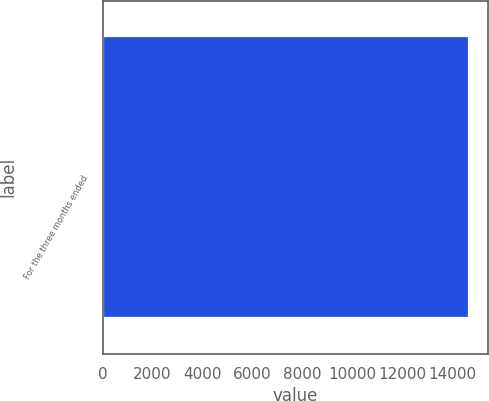Convert chart. <chart><loc_0><loc_0><loc_500><loc_500><bar_chart><fcel>For the three months ended<nl><fcel>14686<nl></chart> 